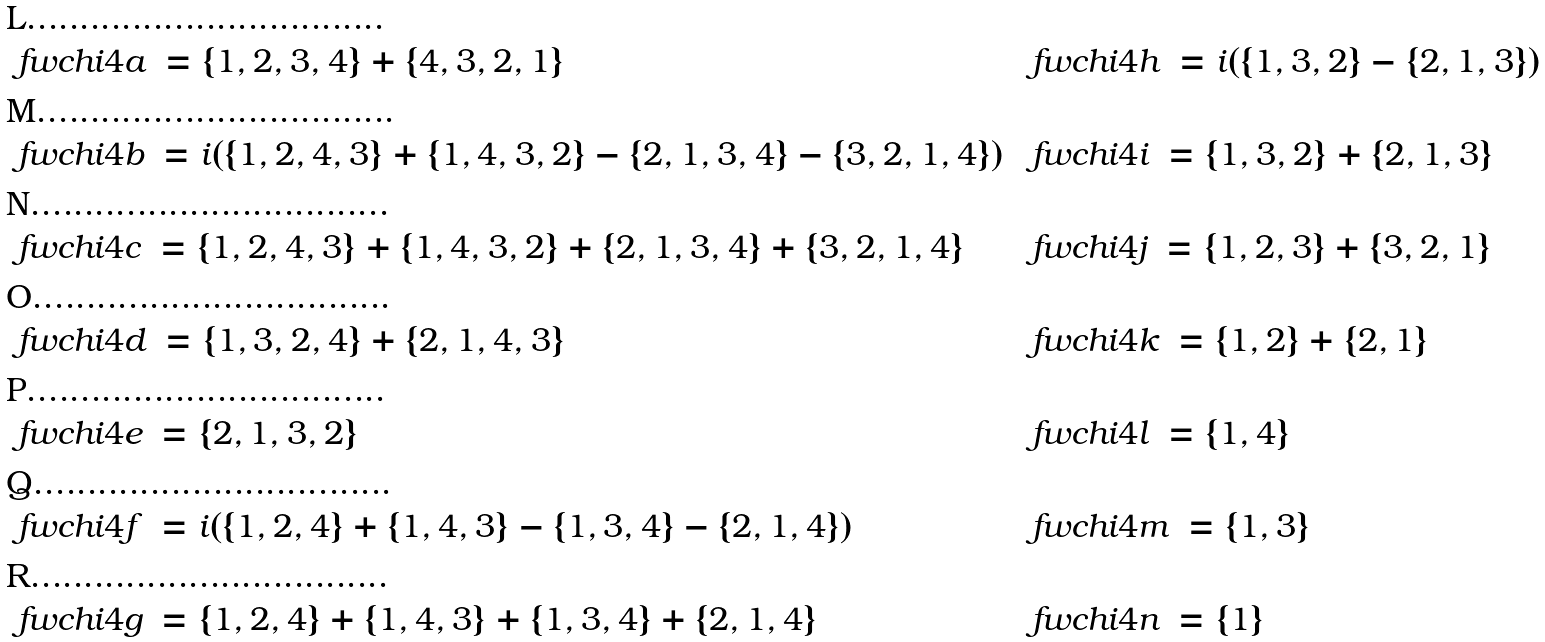Convert formula to latex. <formula><loc_0><loc_0><loc_500><loc_500>& \ f w c h i { 4 a } \, = \{ 1 , 2 , 3 , 4 \} + \{ 4 , 3 , 2 , 1 \} & & \ f w c h i { 4 h } \, = i ( \{ 1 , 3 , 2 \} - \{ 2 , 1 , 3 \} ) \\ & \ f w c h i { 4 b } \, = i ( \{ 1 , 2 , 4 , 3 \} + \{ 1 , 4 , 3 , 2 \} - \{ 2 , 1 , 3 , 4 \} - \{ 3 , 2 , 1 , 4 \} ) & & \ f w c h i { 4 i } \, = \{ 1 , 3 , 2 \} + \{ 2 , 1 , 3 \} \\ & \ f w c h i { 4 c } \, = \{ 1 , 2 , 4 , 3 \} + \{ 1 , 4 , 3 , 2 \} + \{ 2 , 1 , 3 , 4 \} + \{ 3 , 2 , 1 , 4 \} & & \ f w c h i { 4 j } \, = \{ 1 , 2 , 3 \} + \{ 3 , 2 , 1 \} \\ & \ f w c h i { 4 d } \, = \{ 1 , 3 , 2 , 4 \} + \{ 2 , 1 , 4 , 3 \} & & \ f w c h i { 4 k } \, = \{ 1 , 2 \} + \{ 2 , 1 \} \\ & \ f w c h i { 4 e } \, = \{ 2 , 1 , 3 , 2 \} & & \ f w c h i { 4 l } \, = \{ 1 , 4 \} \\ & \ f w c h i { 4 f } \, = i ( \{ 1 , 2 , 4 \} + \{ 1 , 4 , 3 \} - \{ 1 , 3 , 4 \} - \{ 2 , 1 , 4 \} ) & & \ f w c h i { 4 m } \, = \{ 1 , 3 \} \\ & \ f w c h i { 4 g } \, = \{ 1 , 2 , 4 \} + \{ 1 , 4 , 3 \} + \{ 1 , 3 , 4 \} + \{ 2 , 1 , 4 \} & & \ f w c h i { 4 n } \, = \{ 1 \}</formula> 